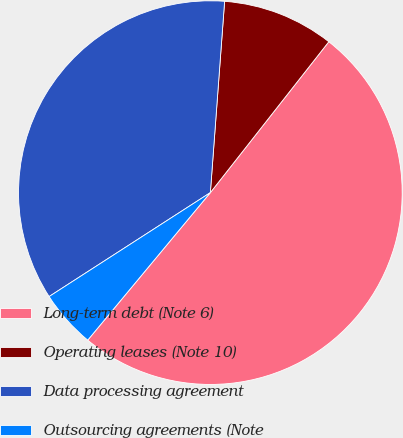Convert chart. <chart><loc_0><loc_0><loc_500><loc_500><pie_chart><fcel>Long-term debt (Note 6)<fcel>Operating leases (Note 10)<fcel>Data processing agreement<fcel>Outsourcing agreements (Note<nl><fcel>50.45%<fcel>9.41%<fcel>35.3%<fcel>4.85%<nl></chart> 